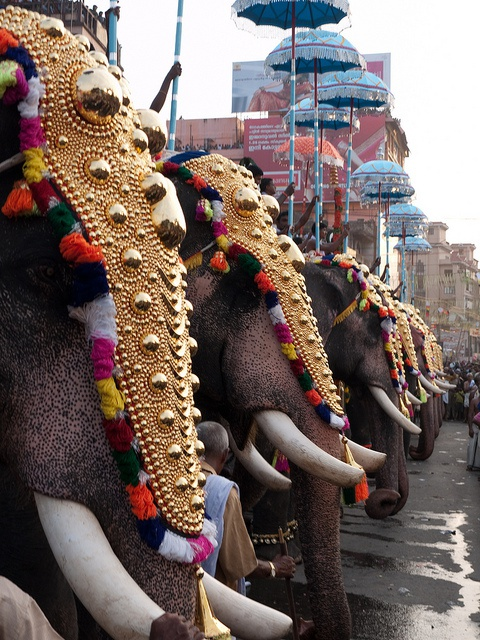Describe the objects in this image and their specific colors. I can see elephant in black, maroon, gray, and darkgray tones, elephant in black, maroon, gray, and darkgray tones, elephant in black, gray, and maroon tones, people in black, gray, and maroon tones, and elephant in black, maroon, gray, and tan tones in this image. 